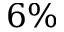Convert formula to latex. <formula><loc_0><loc_0><loc_500><loc_500>6 \%</formula> 